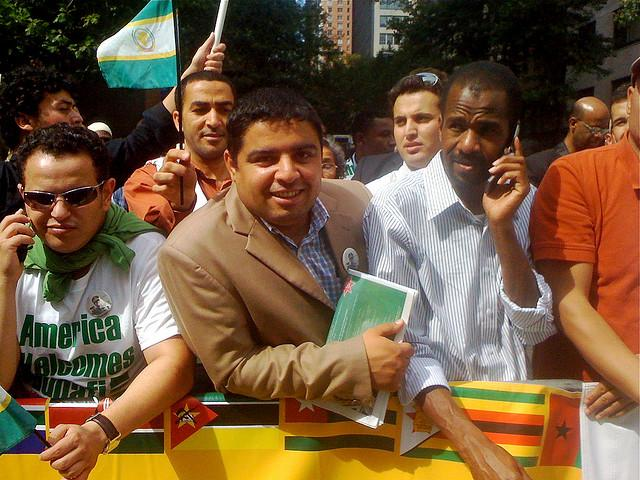What is the man holding the paper wearing?

Choices:
A) glasses
B) gas mask
C) suit
D) cowboy hat suit 